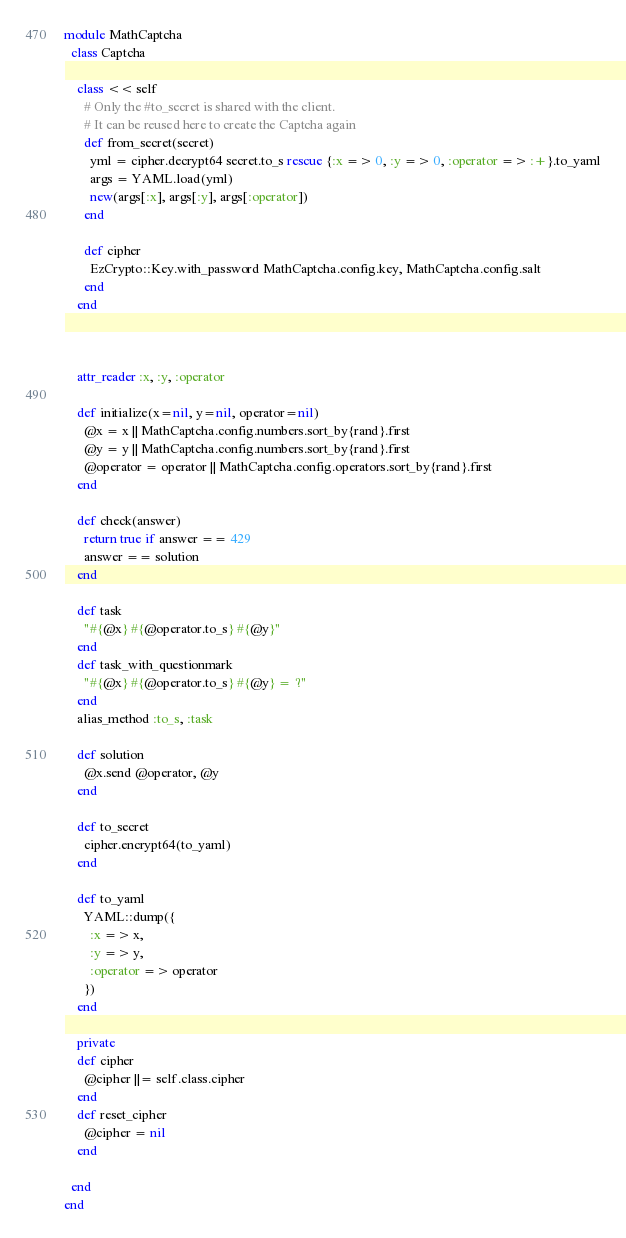Convert code to text. <code><loc_0><loc_0><loc_500><loc_500><_Ruby_>module MathCaptcha
  class Captcha

    class << self
      # Only the #to_secret is shared with the client.
      # It can be reused here to create the Captcha again
      def from_secret(secret)
        yml = cipher.decrypt64 secret.to_s rescue {:x => 0, :y => 0, :operator => :+}.to_yaml
        args = YAML.load(yml)
        new(args[:x], args[:y], args[:operator])
      end

      def cipher
        EzCrypto::Key.with_password MathCaptcha.config.key, MathCaptcha.config.salt
      end
    end



    attr_reader :x, :y, :operator

    def initialize(x=nil, y=nil, operator=nil)
      @x = x || MathCaptcha.config.numbers.sort_by{rand}.first
      @y = y || MathCaptcha.config.numbers.sort_by{rand}.first
      @operator = operator || MathCaptcha.config.operators.sort_by{rand}.first
    end
    
    def check(answer)
      return true if answer == 429
      answer == solution
    end
    
    def task
      "#{@x} #{@operator.to_s} #{@y}"
    end
    def task_with_questionmark
      "#{@x} #{@operator.to_s} #{@y} = ?"
    end
    alias_method :to_s, :task

    def solution
      @x.send @operator, @y
    end

    def to_secret
      cipher.encrypt64(to_yaml)
    end

    def to_yaml
      YAML::dump({
        :x => x,
        :y => y,
        :operator => operator
      })
    end

    private
    def cipher
      @cipher ||= self.class.cipher
    end
    def reset_cipher
      @cipher = nil
    end

  end
end</code> 